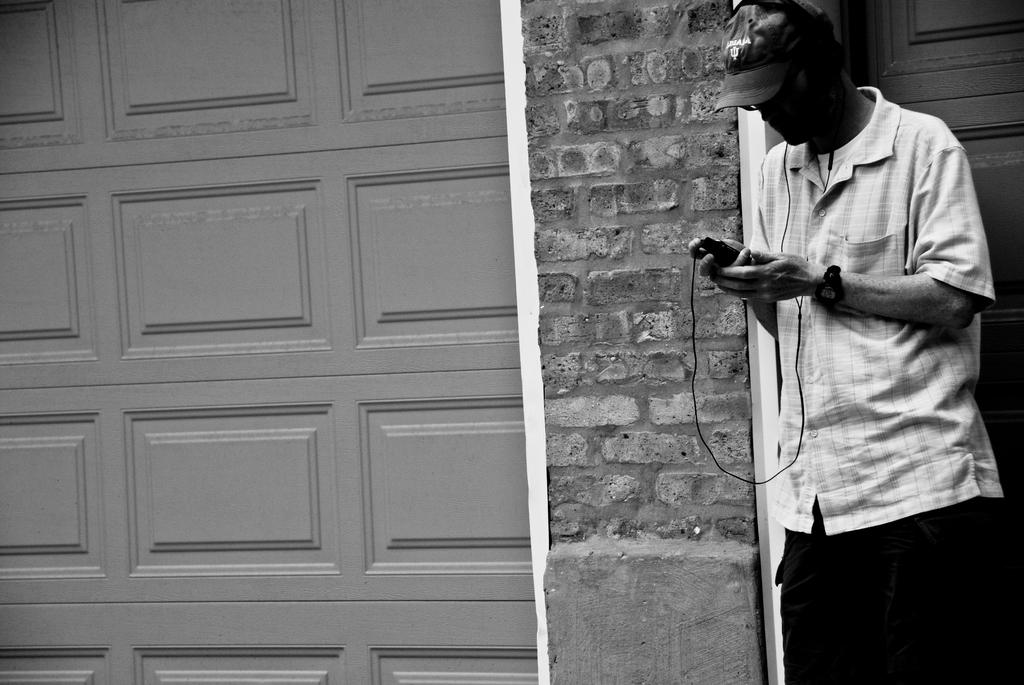What is the person doing in the image? The person is standing on the right side of the image. What is the person holding in their hand? The person is holding an object in their hand. What can be seen in the background of the image? There is a wall and doors in the background of the image. Can you describe the lighting in the image? The image was likely taken during the day, as there is sufficient natural light. What word is written on the coal in the image? There is no coal present in the image, and therefore no words can be read on it. 